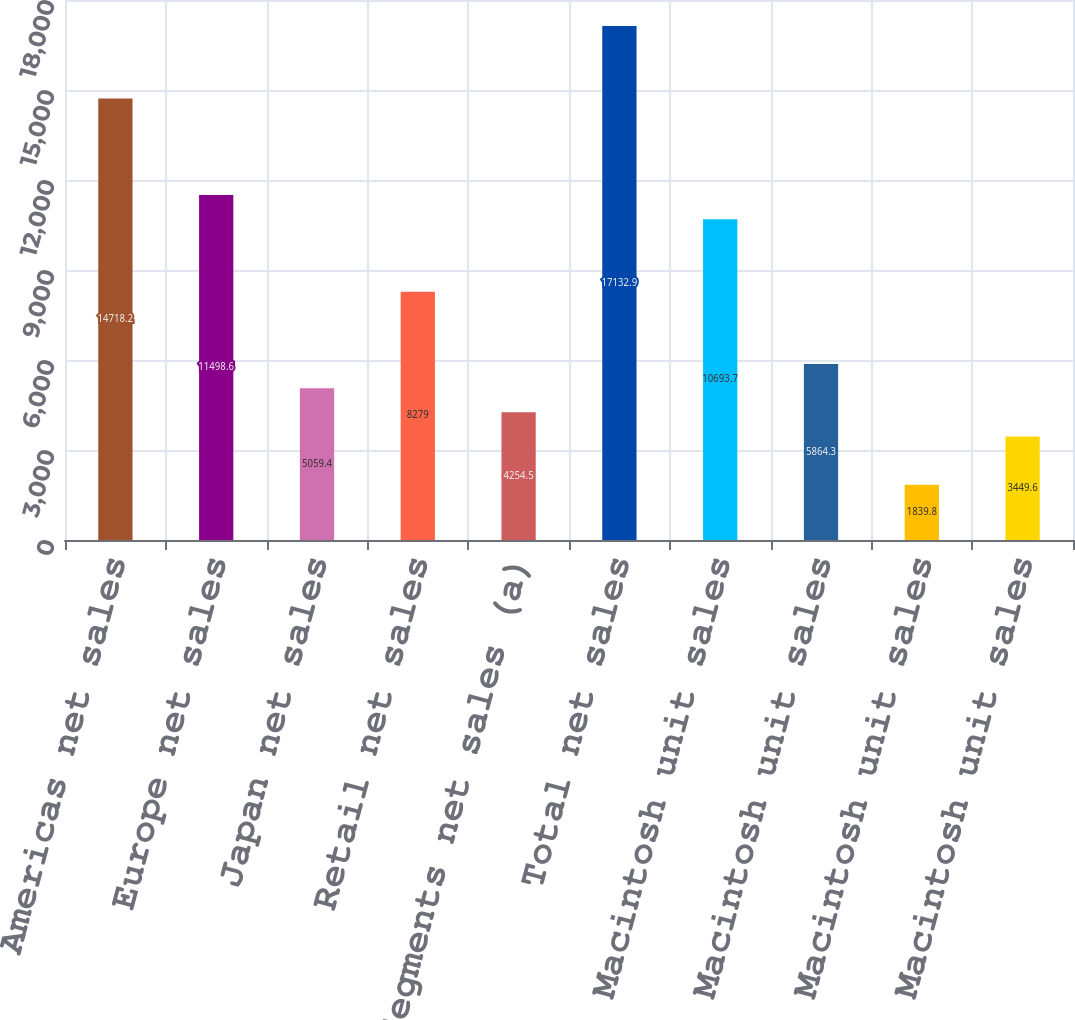Convert chart to OTSL. <chart><loc_0><loc_0><loc_500><loc_500><bar_chart><fcel>Americas net sales<fcel>Europe net sales<fcel>Japan net sales<fcel>Retail net sales<fcel>Other Segments net sales (a)<fcel>Total net sales<fcel>Americas Macintosh unit sales<fcel>Europe Macintosh unit sales<fcel>Japan Macintosh unit sales<fcel>Retail Macintosh unit sales<nl><fcel>14718.2<fcel>11498.6<fcel>5059.4<fcel>8279<fcel>4254.5<fcel>17132.9<fcel>10693.7<fcel>5864.3<fcel>1839.8<fcel>3449.6<nl></chart> 